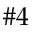<formula> <loc_0><loc_0><loc_500><loc_500>\# 4</formula> 